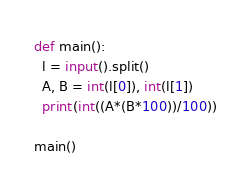<code> <loc_0><loc_0><loc_500><loc_500><_Python_>def main():
  l = input().split()
  A, B = int(l[0]), int(l[1])
  print(int((A*(B*100))/100))

main()
</code> 